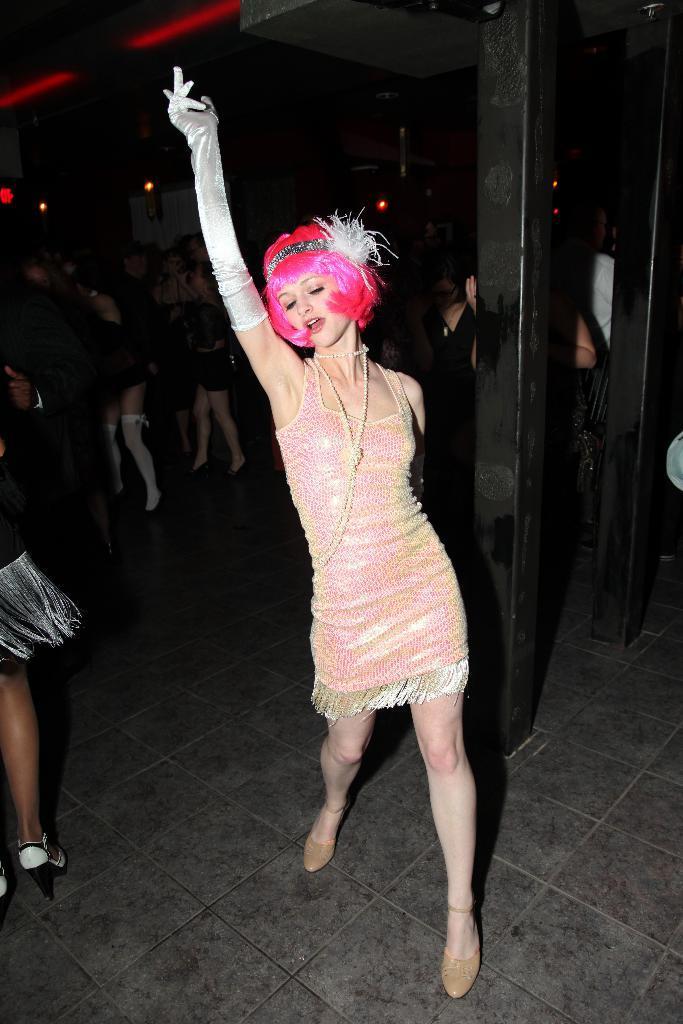Could you give a brief overview of what you see in this image? In this picture I can see groups of people dancing on the floor. And there is a pillar. 